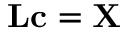<formula> <loc_0><loc_0><loc_500><loc_500>L c = X</formula> 